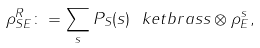<formula> <loc_0><loc_0><loc_500><loc_500>\rho ^ { R } _ { S E } \colon = \sum _ { s } P _ { S } ( s ) \ k e t b r a { s } { s } \otimes \rho _ { E } ^ { s } ,</formula> 